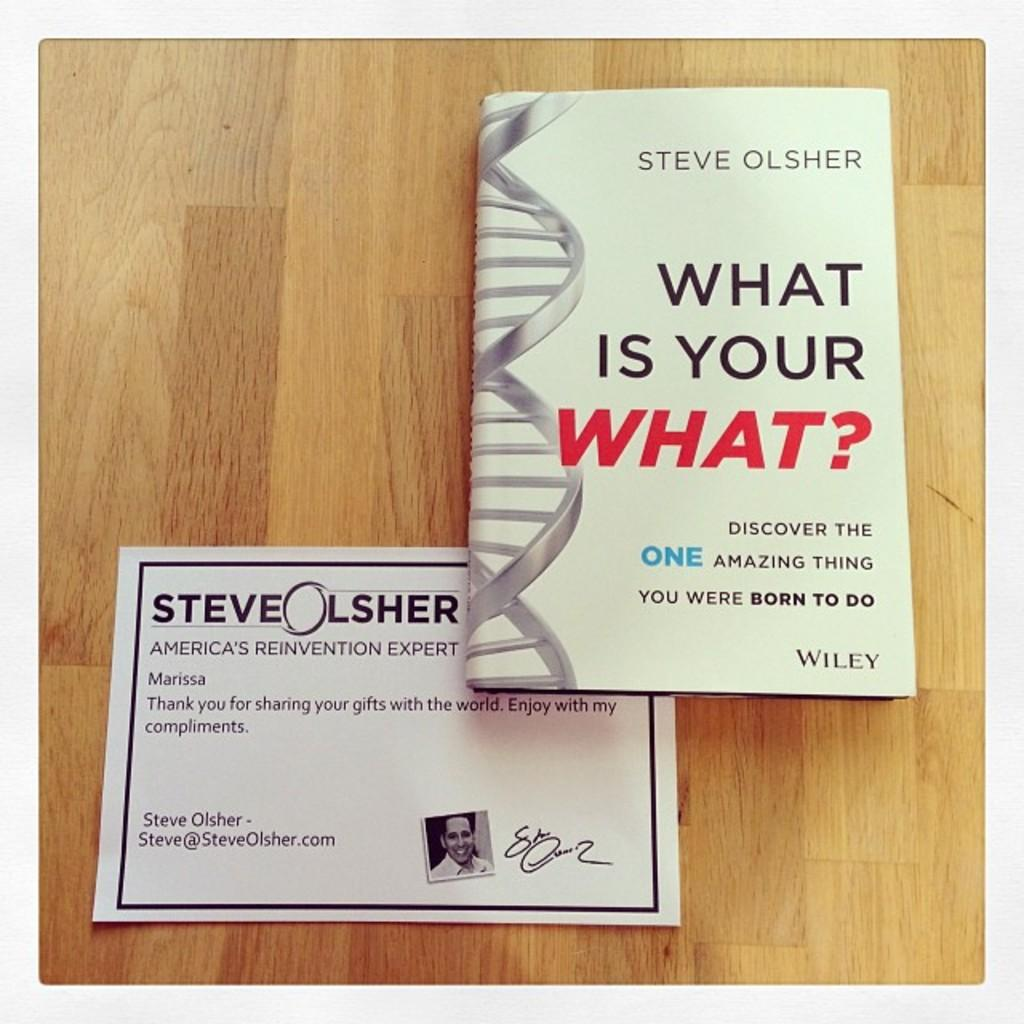<image>
Offer a succinct explanation of the picture presented. A book by Steve Olsher is shown with a note below. 